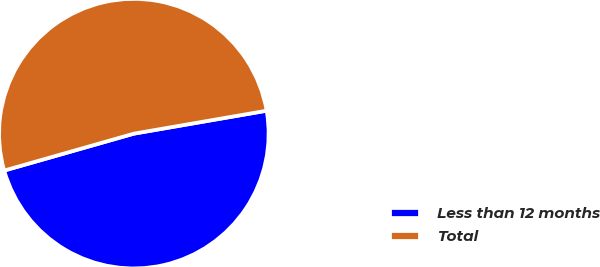Convert chart to OTSL. <chart><loc_0><loc_0><loc_500><loc_500><pie_chart><fcel>Less than 12 months<fcel>Total<nl><fcel>48.31%<fcel>51.69%<nl></chart> 